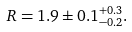Convert formula to latex. <formula><loc_0><loc_0><loc_500><loc_500>R = 1 . 9 \pm 0 . 1 ^ { + 0 . 3 } _ { - 0 . 2 } .</formula> 